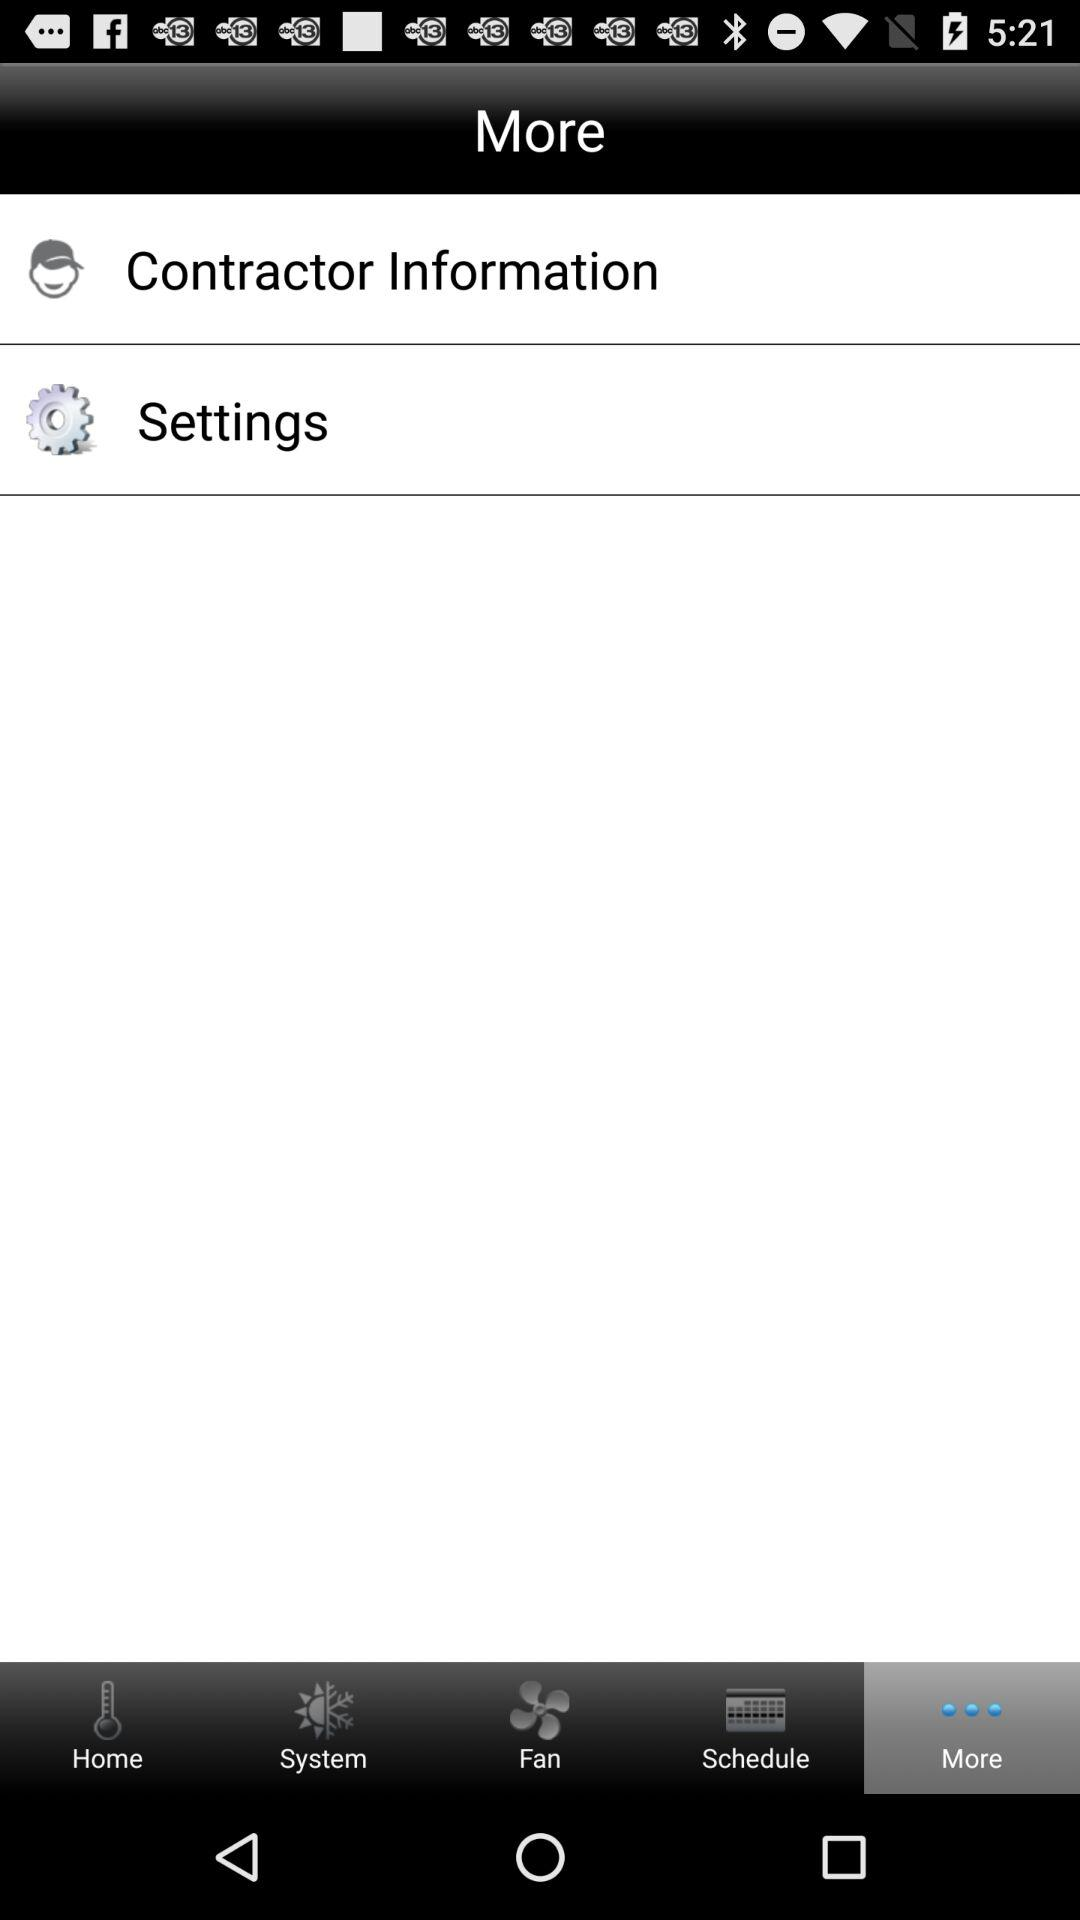What is the name of the application?
When the provided information is insufficient, respond with <no answer>. <no answer> 